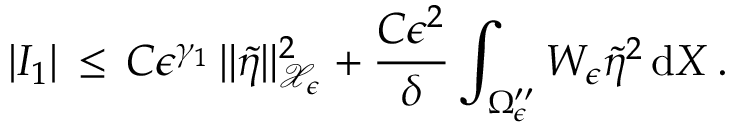Convert formula to latex. <formula><loc_0><loc_0><loc_500><loc_500>| I _ { 1 } | \, \leq \, C \epsilon ^ { \gamma _ { 1 } } \, \| \tilde { \eta } \| _ { \mathcal { X } _ { \epsilon } } ^ { 2 } + \frac { C \epsilon ^ { 2 } } { \delta } \int _ { \Omega _ { \epsilon } ^ { \prime \prime } } W _ { \epsilon } \tilde { \eta } ^ { 2 } \, d X \, .</formula> 